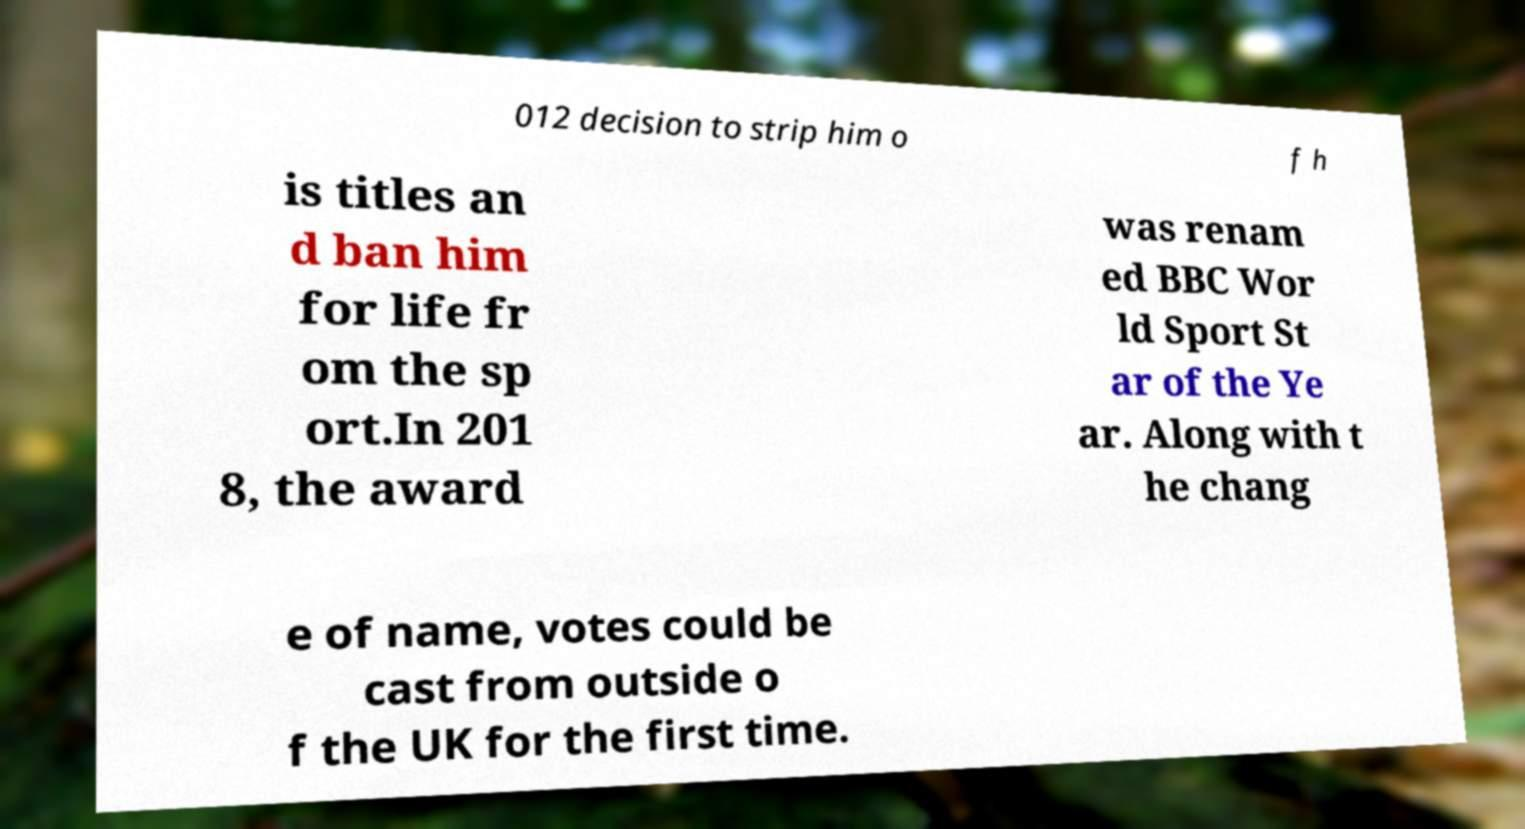Can you read and provide the text displayed in the image?This photo seems to have some interesting text. Can you extract and type it out for me? 012 decision to strip him o f h is titles an d ban him for life fr om the sp ort.In 201 8, the award was renam ed BBC Wor ld Sport St ar of the Ye ar. Along with t he chang e of name, votes could be cast from outside o f the UK for the first time. 